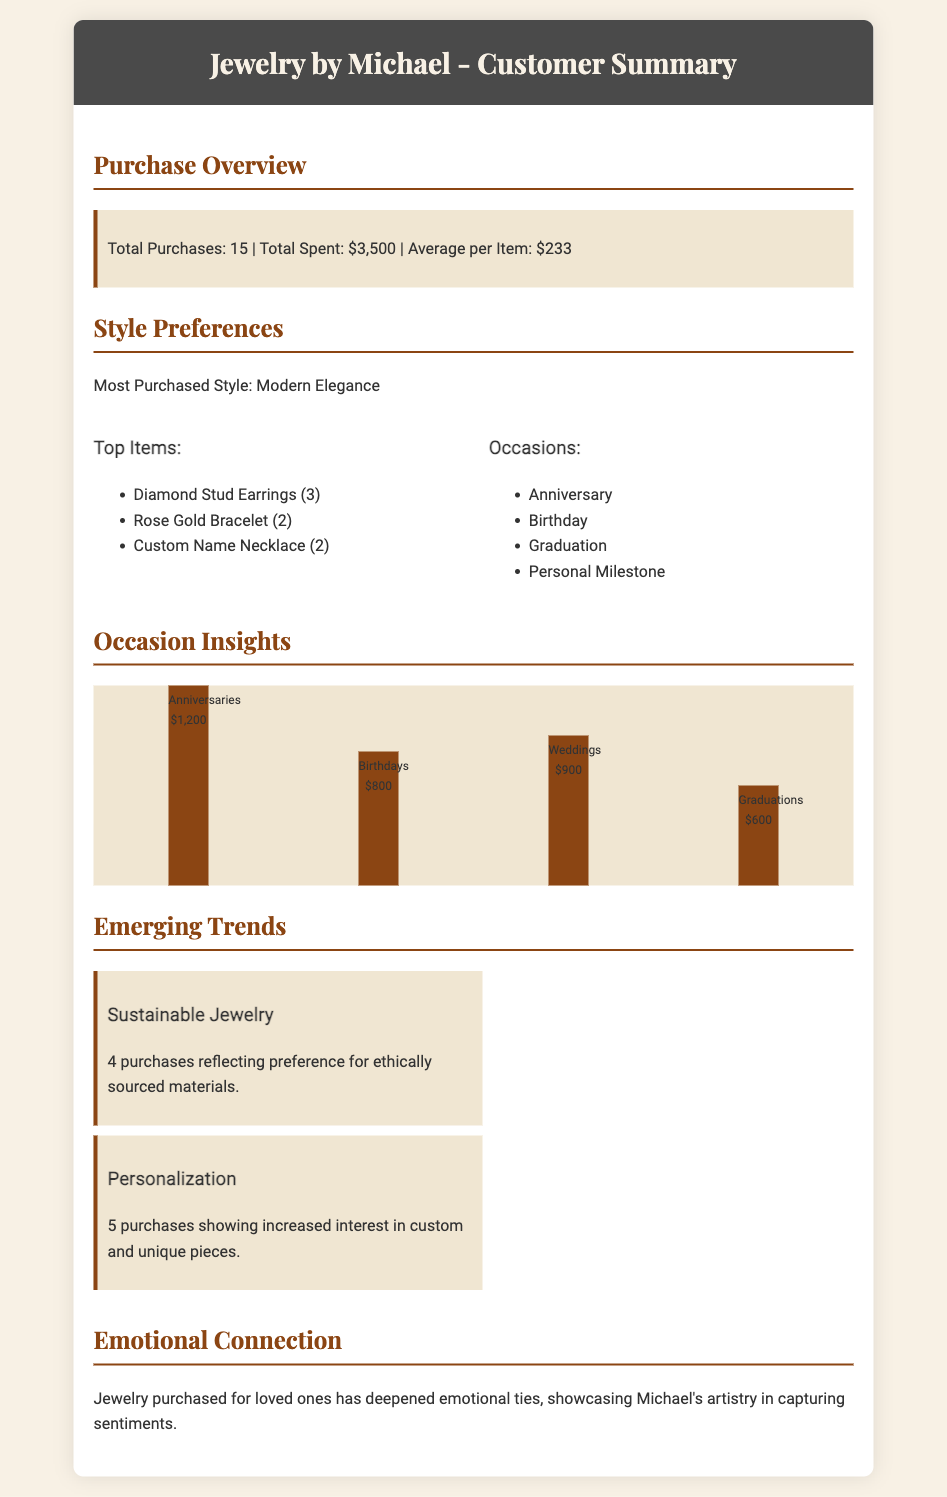what was the total number of purchases? The document states the total purchases made was 15.
Answer: 15 what is the total amount spent? The total amount spent is detailed in the purchase overview, which is $3,500.
Answer: $3,500 which style was the most purchased? The document notes that the most purchased style was Modern Elegance.
Answer: Modern Elegance how much was spent on anniversaries? The occasion insights section mentions that $1,200 was spent on anniversaries.
Answer: $1,200 how many purchases reflected a preference for sustainable jewelry? The emerging trends section indicates there were 4 purchases reflecting a preference for sustainable jewelry.
Answer: 4 what was the average amount spent per item? The document calculates the average spent per item as $233, in the purchase overview.
Answer: $233 how many purchases were made for birthdays? Based on the occasion insights, the amount spent on birthdays was $800, highlighting purchases for this occasion.
Answer: 800 what was the total number of custom pieces purchased? The document states that there were 5 purchases showing increased interest in custom and unique pieces.
Answer: 5 which occasions were the top highlighted for jewelry purchases? The occasions listed are Anniversary, Birthday, Graduation, and Personal Milestone, showcasing diverse reasons for purchases.
Answer: Anniversary, Birthday, Graduation, Personal Milestone 